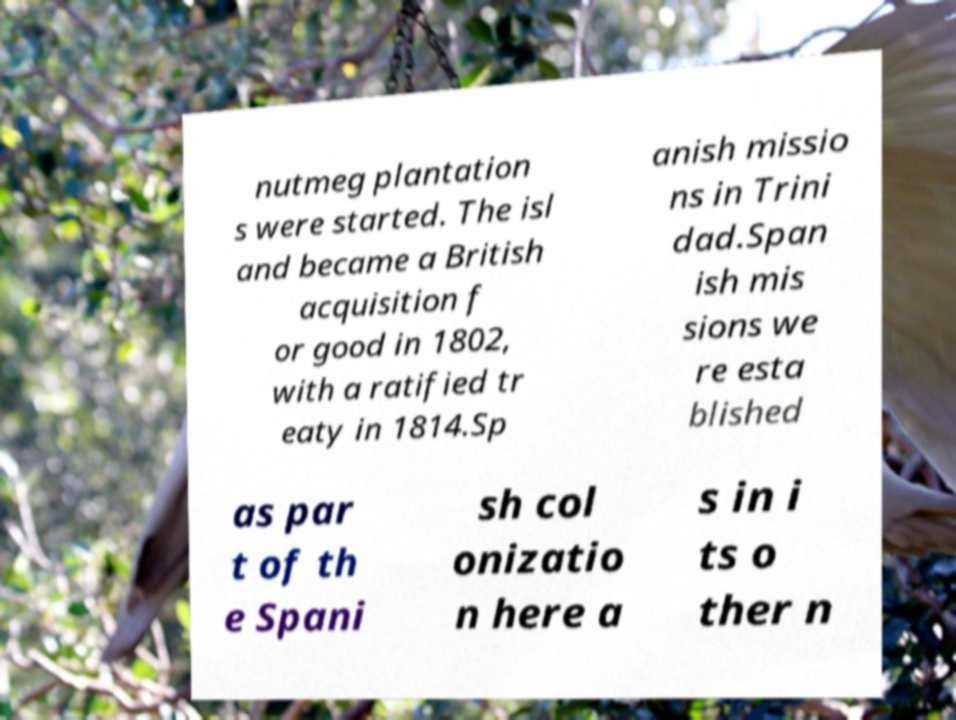Please read and relay the text visible in this image. What does it say? nutmeg plantation s were started. The isl and became a British acquisition f or good in 1802, with a ratified tr eaty in 1814.Sp anish missio ns in Trini dad.Span ish mis sions we re esta blished as par t of th e Spani sh col onizatio n here a s in i ts o ther n 